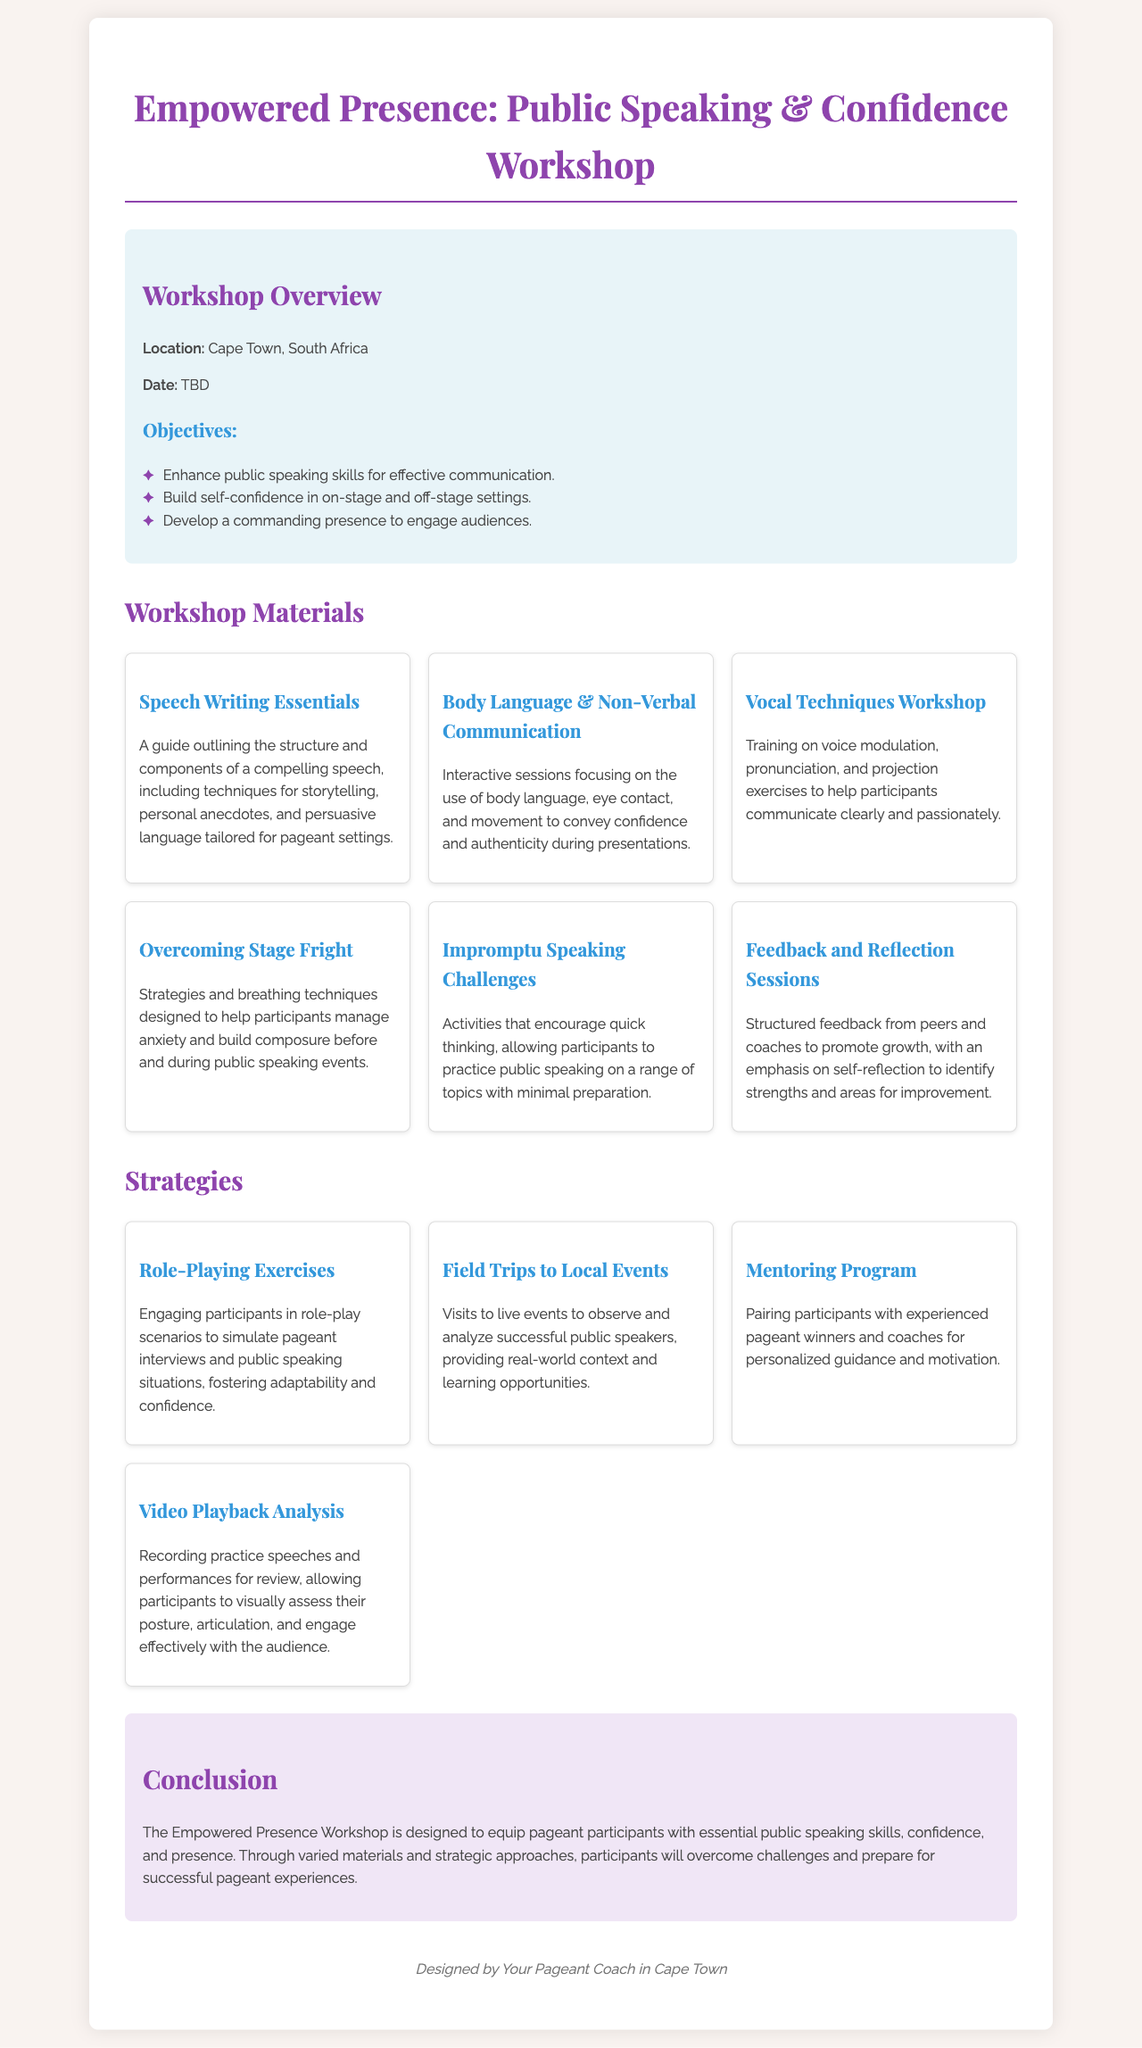What is the workshop location? The workshop location is specified in the document under the workshop overview section.
Answer: Cape Town, South Africa What is one objective of the workshop? The document lists several objectives, one of which is highlighted in the objectives section.
Answer: Enhance public speaking skills How many workshop materials are listed? The materials section includes a total count of distinct items listed as workshop materials.
Answer: Six What is the title of the workshop? The title of the workshop is prominently displayed at the top of the document.
Answer: Empowered Presence: Public Speaking & Confidence Workshop What technique is taught to overcome nervousness? Techniques for managing anxiety and building composure are included in the document under a specific workshop material.
Answer: Breathing techniques What type of exercises are included in the strategies section? The strategies section identifies specific types of engaging activities aimed at enhancing participant skills.
Answer: Role-Playing Exercises Who can participants pair with in the mentoring program? The document specifies the type of individuals participants will be paired with for guidance in the mentoring program.
Answer: Experienced pageant winners What is included in the conclusion? The conclusion summarizes the main intent of the workshop, which is provided in the conclusion section of the document.
Answer: Equip pageant participants with essential public speaking skills What is the focus of the vocal techniques workshop? Details about the vocal techniques workshop are provided, emphasizing key areas of focus for participants.
Answer: Voice modulation, pronunciation, and projection exercises 